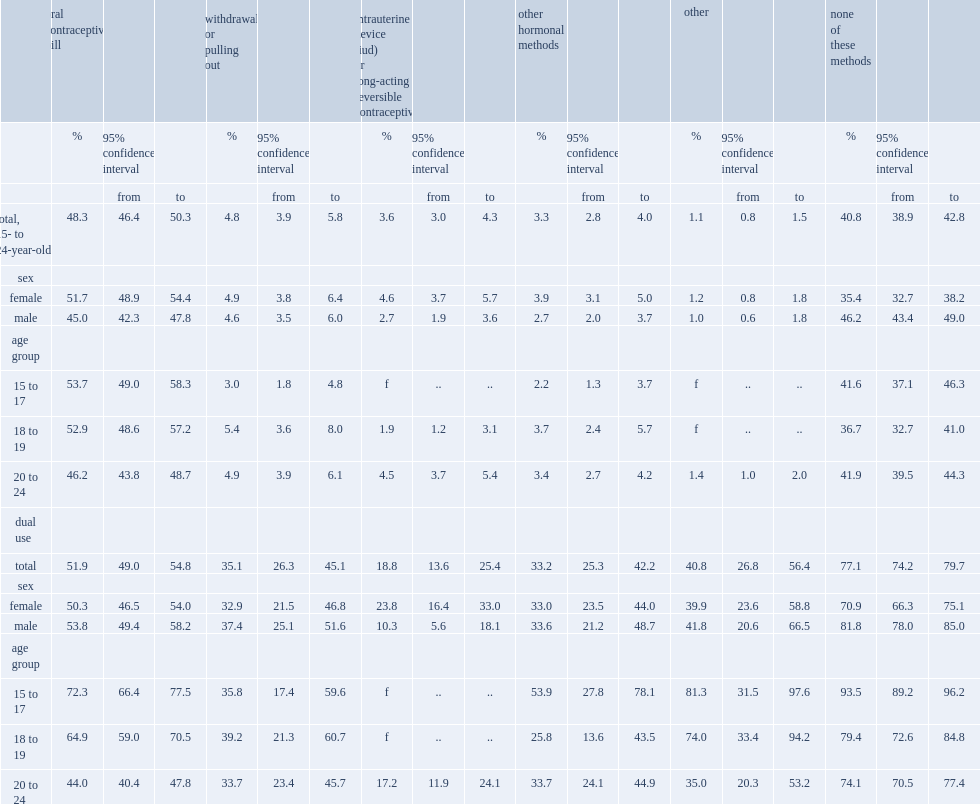What was the percentage of currently sexually active 15- to 24-year-olds reported that they or their partner were using ocps the last time they had intercourse? 48.3. What was the percentage of currently sexually active 15- to 24-year-olds reported that they used withdrawal? 4.8. What was the percentage of people aged 15 to 17 used ocp? 53.7. What was the percentage of people aged 20 to 24 used ocp? 46.2. What was the percentage of ocp users aged 15 to 17 have also used a condom? 72.3. What was the percentage of ocp users aged 20 to 24 have also used a condom? 44.0. 